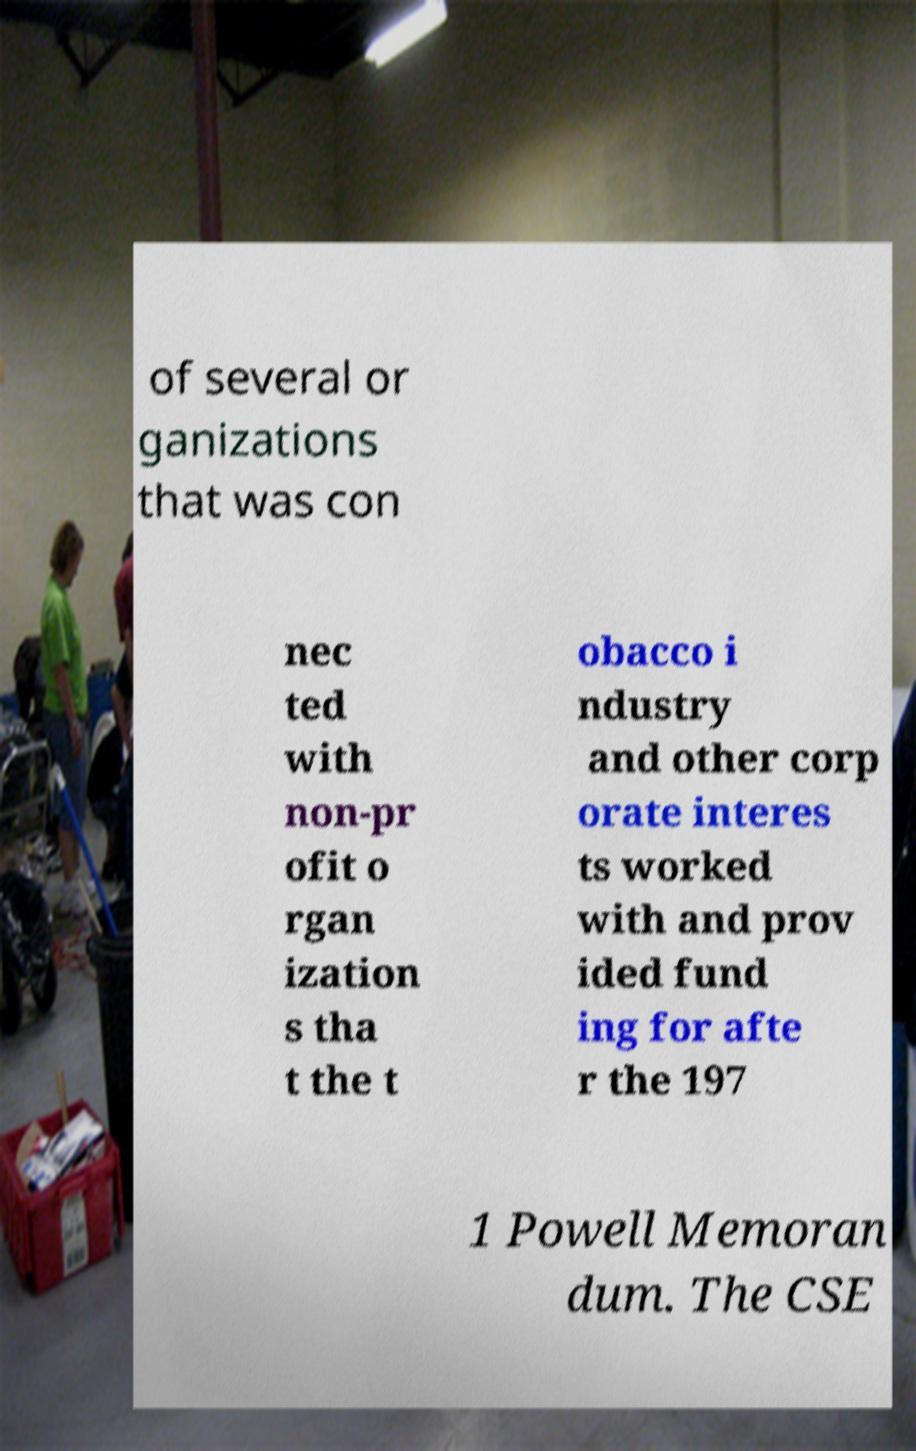I need the written content from this picture converted into text. Can you do that? of several or ganizations that was con nec ted with non-pr ofit o rgan ization s tha t the t obacco i ndustry and other corp orate interes ts worked with and prov ided fund ing for afte r the 197 1 Powell Memoran dum. The CSE 